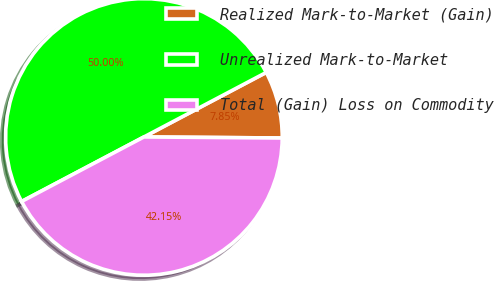Convert chart to OTSL. <chart><loc_0><loc_0><loc_500><loc_500><pie_chart><fcel>Realized Mark-to-Market (Gain)<fcel>Unrealized Mark-to-Market<fcel>Total (Gain) Loss on Commodity<nl><fcel>7.85%<fcel>50.0%<fcel>42.15%<nl></chart> 